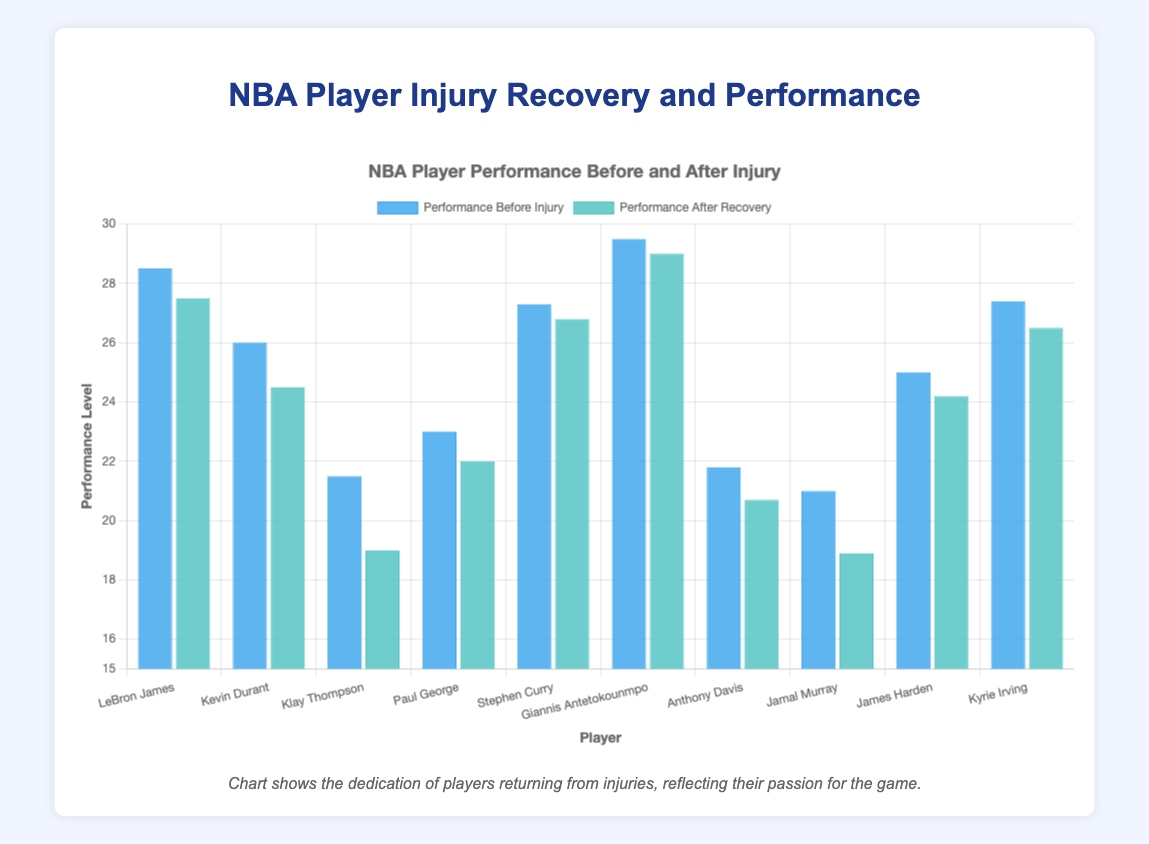What's the longest recovery time among the players? To find the longest recovery time, look at the 'Recovery Time (weeks)' bars and identify the maximum value among them.
Answer: 52 weeks Which player has the highest performance level after recovery? Compare the height of the 'Performance After Recovery' bars for each player and identify the tallest bar.
Answer: Giannis Antetokounmpo Which player from the Golden State Warriors had a longer recovery time, Stephen Curry or Klay Thompson? Compare the 'Recovery Time (weeks)' for Stephen Curry and Klay Thompson based on the length of their respective bars. Klay Thompson's bar is longer.
Answer: Klay Thompson What's the difference in the performance level before and after injury for Kevin Durant? Subtract Kevin Durant's 'Performance After Recovery' value from his 'Performance Before Injury' value: 26.0 - 24.5 = 1.5.
Answer: 1.5 Who improved the most after injury? Calculate the difference between 'Performance After Recovery' and 'Performance Before Injury' for each player and identify the most positive difference. Since all players have lower performance after recovery, we identify the smallest decrease.
Answer: Giannis Antetokounmpo What is the average performance level before injury for all players? Sum up the 'Performance Before Injury' for all players and divide by the number of players: (28.5 + 26.0 + 21.5 + 23.0 + 27.3 + 29.5 + 21.8 + 21.0 + 25.0 + 27.4) / 10 = 25.1.
Answer: 25.1 Which player had the shortest recovery time? Identify the shortest bar in the 'Recovery Time (weeks)' category. LeBron James' bar is the shortest with 4 weeks.
Answer: LeBron James Is there any player whose performance level after recovery is higher than their performance level before injury? Compare the bars for 'Performance Before Injury' and 'Performance After Recovery' for each player to see if any are higher after recovery. All players have lower performance levels after recovery.
Answer: No Who had a recovery time of 8 weeks? Look at the bar lengths for 'Recovery Time (weeks)' and identify the player corresponding to 8 weeks. James Harden's bar matches this length.
Answer: James Harden How many players had a recovery time greater than 40 weeks? Count the number of bars in the 'Recovery Time (weeks)' category that exceed 40 weeks. There are three such players: Kevin Durant, Klay Thompson, and Jamal Murray.
Answer: 3 